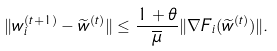Convert formula to latex. <formula><loc_0><loc_0><loc_500><loc_500>\| w ^ { ( t + 1 ) } _ { i } - \widetilde { w } ^ { ( t ) } \| \leq \frac { 1 + \theta } { \overline { \mu } } \| \nabla F _ { i } ( \widetilde { w } ^ { ( t ) } ) \| .</formula> 